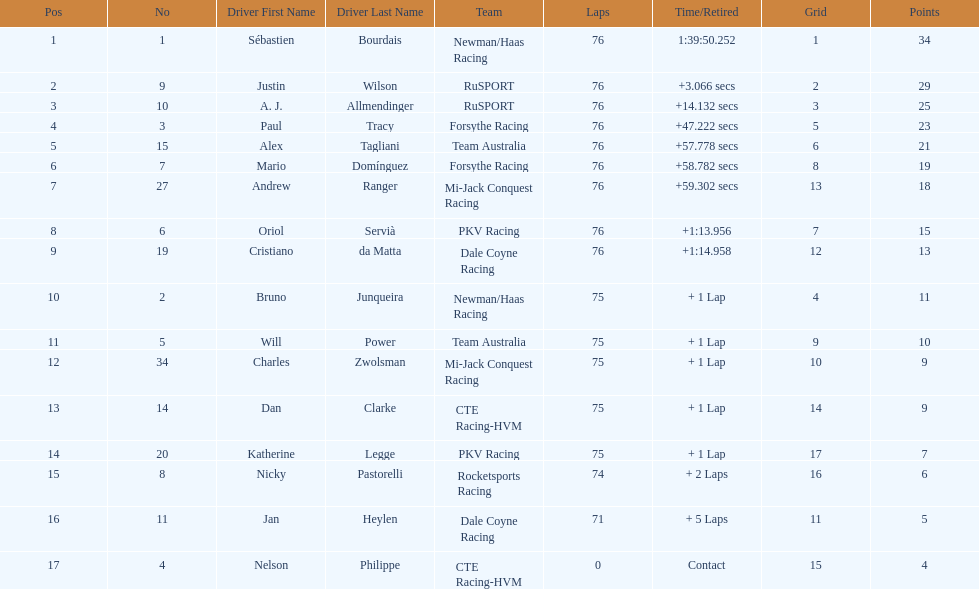What driver earned the most points? Sebastien Bourdais. 